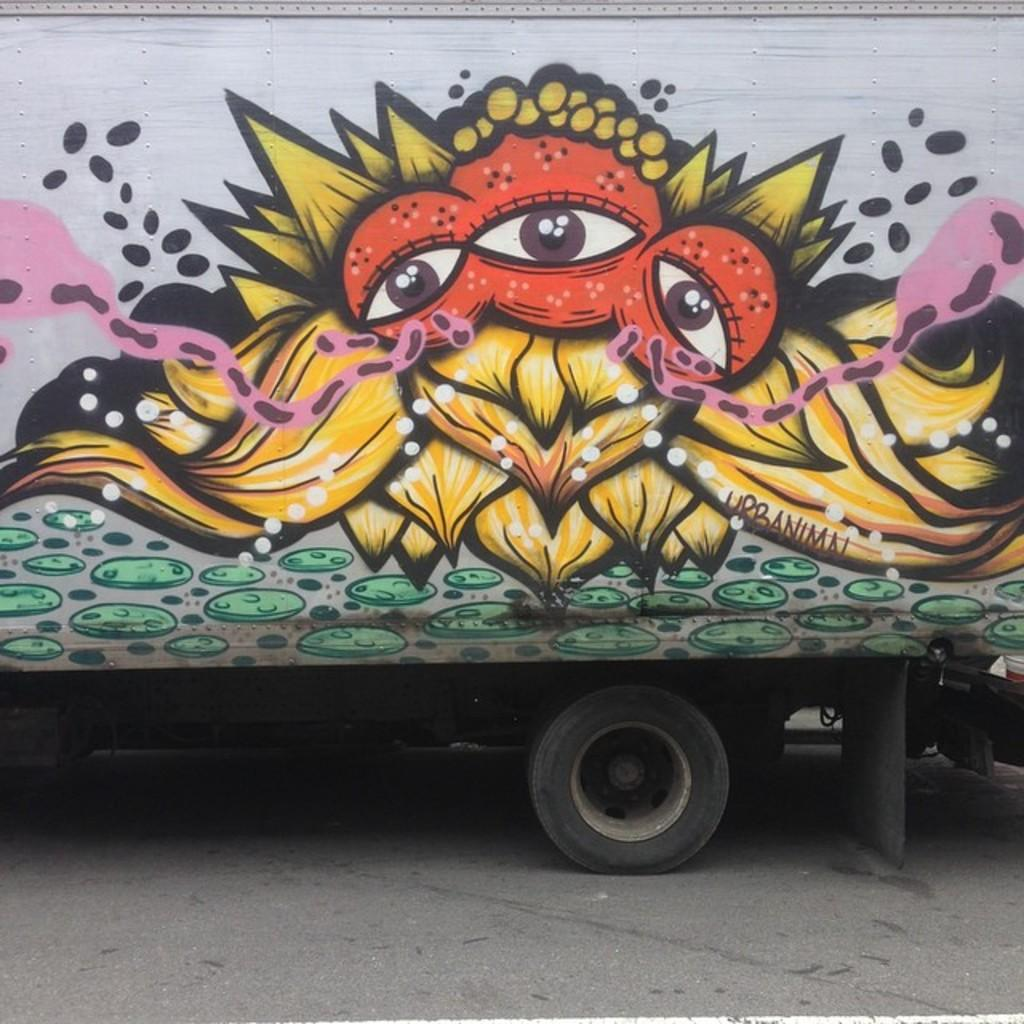What is the main subject of the image? The main subject of the image is a bus. Where is the bus located in the image? The bus is in the center of the image. What feature stands out on the bus? The bus has a painting on it. Can you see a goat taking a bath in the tank on the bus? There is no goat, bath, or tank present in the image; it only features a bus with a painting on it. 